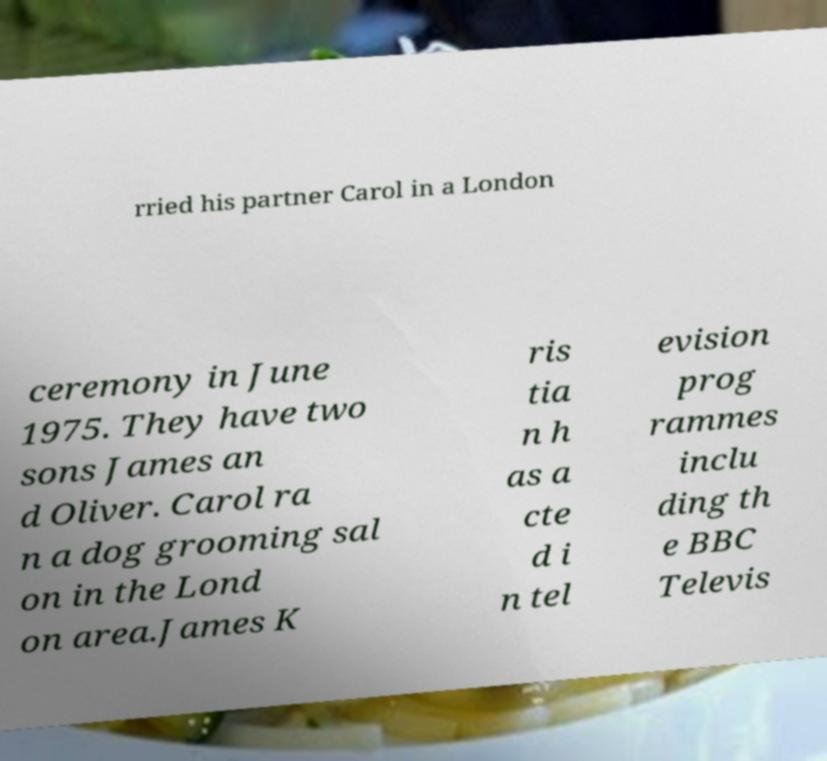I need the written content from this picture converted into text. Can you do that? rried his partner Carol in a London ceremony in June 1975. They have two sons James an d Oliver. Carol ra n a dog grooming sal on in the Lond on area.James K ris tia n h as a cte d i n tel evision prog rammes inclu ding th e BBC Televis 